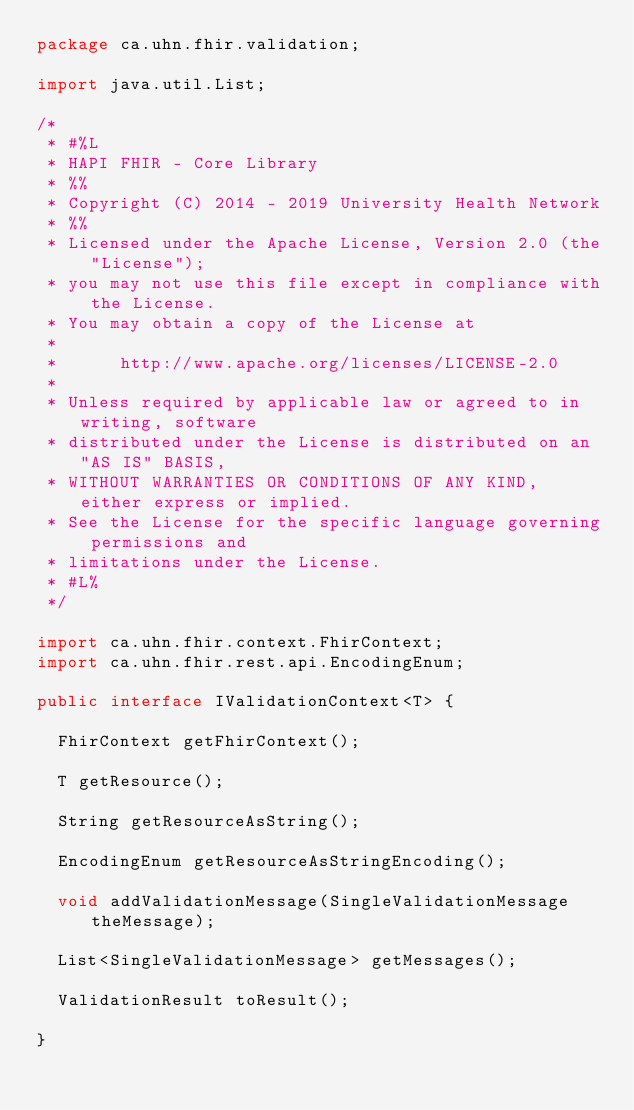Convert code to text. <code><loc_0><loc_0><loc_500><loc_500><_Java_>package ca.uhn.fhir.validation;

import java.util.List;

/*
 * #%L
 * HAPI FHIR - Core Library
 * %%
 * Copyright (C) 2014 - 2019 University Health Network
 * %%
 * Licensed under the Apache License, Version 2.0 (the "License");
 * you may not use this file except in compliance with the License.
 * You may obtain a copy of the License at
 * 
 *      http://www.apache.org/licenses/LICENSE-2.0
 * 
 * Unless required by applicable law or agreed to in writing, software
 * distributed under the License is distributed on an "AS IS" BASIS,
 * WITHOUT WARRANTIES OR CONDITIONS OF ANY KIND, either express or implied.
 * See the License for the specific language governing permissions and
 * limitations under the License.
 * #L%
 */

import ca.uhn.fhir.context.FhirContext;
import ca.uhn.fhir.rest.api.EncodingEnum;

public interface IValidationContext<T> {

	FhirContext getFhirContext();

	T getResource();

	String getResourceAsString();

	EncodingEnum getResourceAsStringEncoding();

	void addValidationMessage(SingleValidationMessage theMessage);

	List<SingleValidationMessage> getMessages();
	
	ValidationResult toResult();

}
</code> 